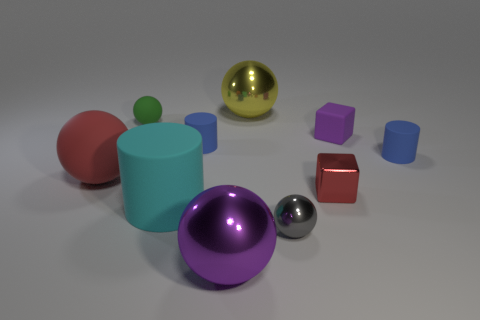How many tiny cylinders are there?
Give a very brief answer. 2. The object that is both to the left of the big cyan cylinder and behind the small purple object has what shape?
Ensure brevity in your answer.  Sphere. There is a small gray object that is to the right of the sphere behind the small ball to the left of the big cyan thing; what is its shape?
Offer a very short reply. Sphere. There is a big thing that is both behind the purple metallic ball and to the right of the cyan thing; what is its material?
Give a very brief answer. Metal. What number of red shiny objects have the same size as the matte cube?
Provide a succinct answer. 1. How many rubber objects are either large cyan blocks or tiny gray things?
Provide a succinct answer. 0. What material is the gray sphere?
Your answer should be very brief. Metal. There is a cyan rubber cylinder; how many metal things are in front of it?
Ensure brevity in your answer.  2. Are the big object that is on the right side of the purple shiny object and the big red ball made of the same material?
Provide a succinct answer. No. What number of tiny blue matte objects have the same shape as the small red object?
Your response must be concise. 0. 